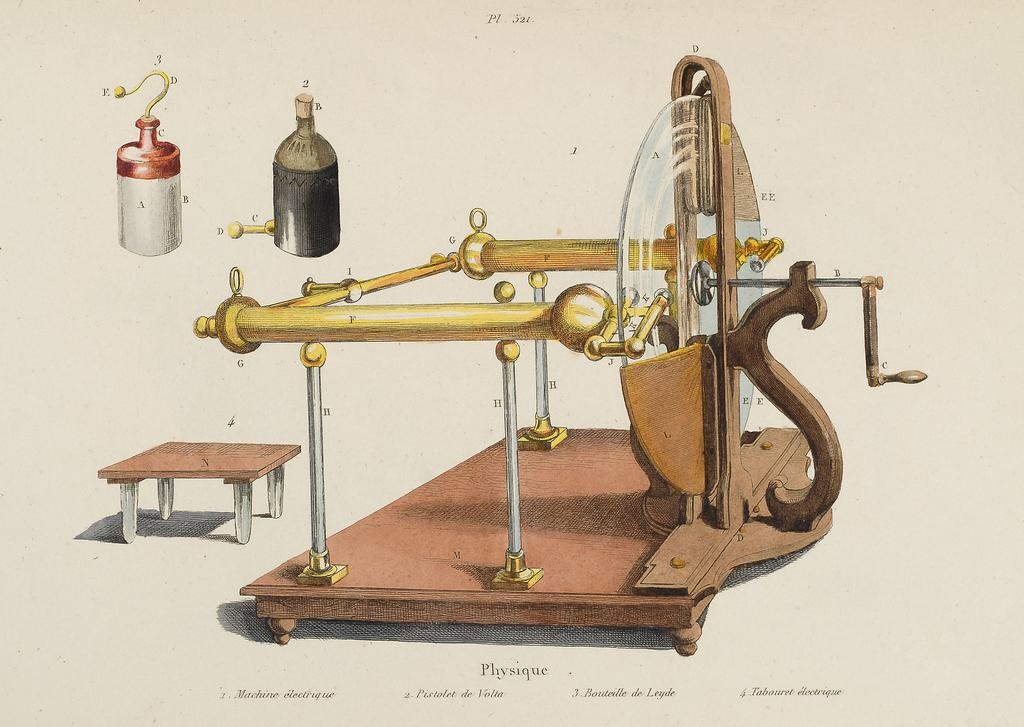What can be seen on the wall in the image? There is a poster on the wall in the image. What is located on the right side of the image? There is a machine on the right side of the image. What is on the left side of the image? There is a table on the left side of the image. Where are the bottles in the image? The two bottles are in the top left corner of the image. Can you describe the fairies flying around the machine in the image? There are no fairies present in the image; the focus is on the machine, table, poster, and bottles. 